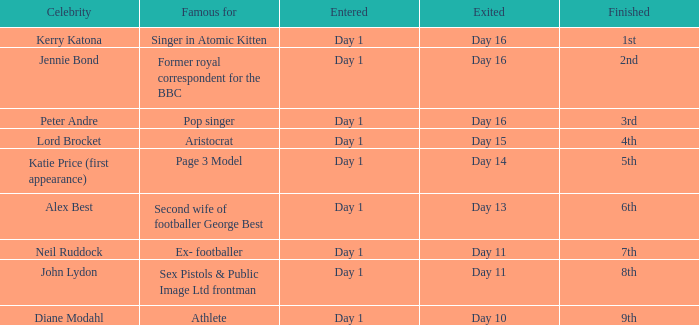Identify the completed for kerry katona. 1.0. 